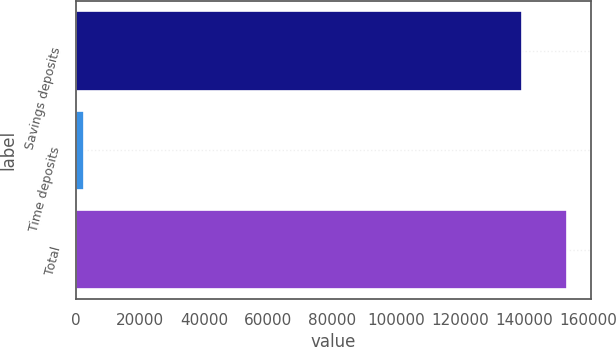Convert chart. <chart><loc_0><loc_0><loc_500><loc_500><bar_chart><fcel>Savings deposits<fcel>Time deposits<fcel>Total<nl><fcel>139169<fcel>2333<fcel>153086<nl></chart> 